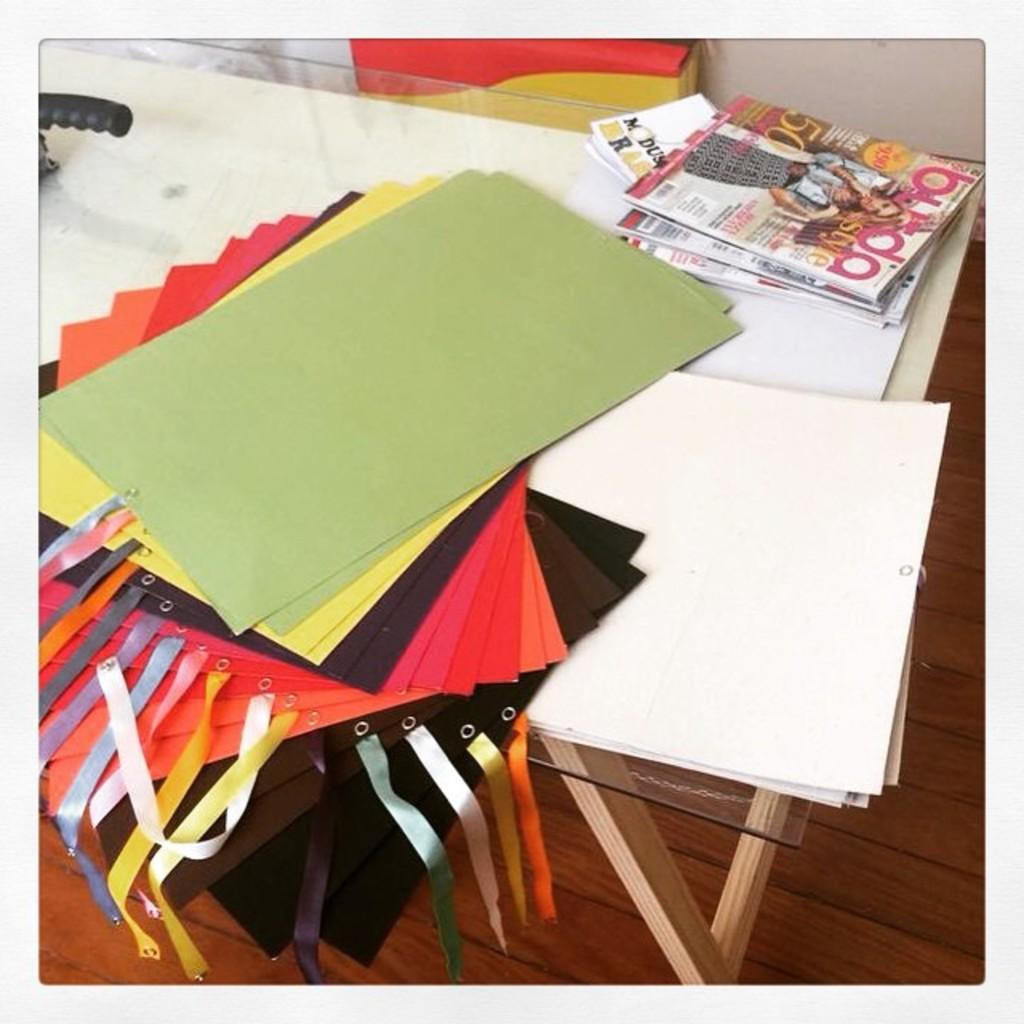What type of surface is the papers and books placed on in the image? The papers and books are placed on a glass table in the image. What other objects can be seen on the glass table? There are other objects on the glass table in the image. What is visible in the background of the image? There is a wall and a box in the background of the image. What type of summer competition is taking place in the image? There is no summer competition present in the image. Are there any giants visible in the image? There are no giants present in the image. 